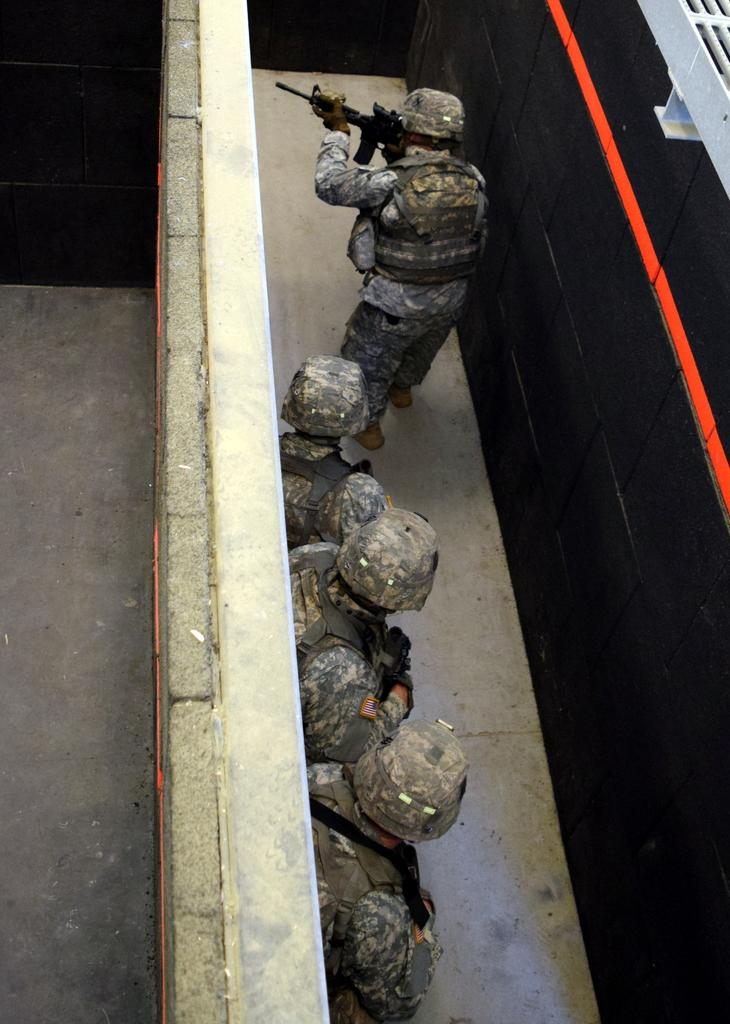What type of people can be seen in the image? There are army people in the image. Where are the army people positioned? The army people are standing between walls. What type of machine can be heard making a voice in the image? There is no machine or voice present in the image; it only features army people standing between walls. 